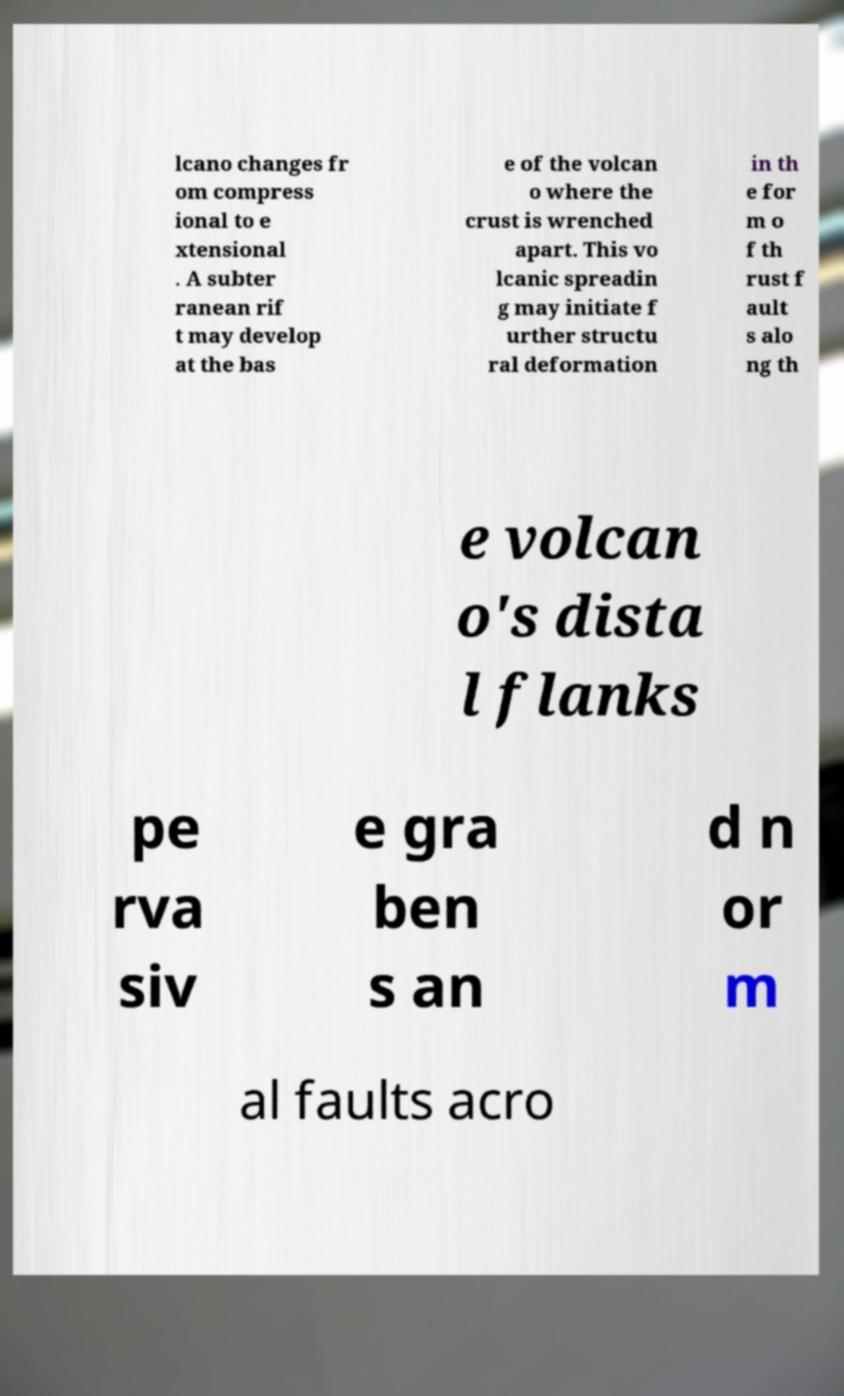I need the written content from this picture converted into text. Can you do that? lcano changes fr om compress ional to e xtensional . A subter ranean rif t may develop at the bas e of the volcan o where the crust is wrenched apart. This vo lcanic spreadin g may initiate f urther structu ral deformation in th e for m o f th rust f ault s alo ng th e volcan o's dista l flanks pe rva siv e gra ben s an d n or m al faults acro 